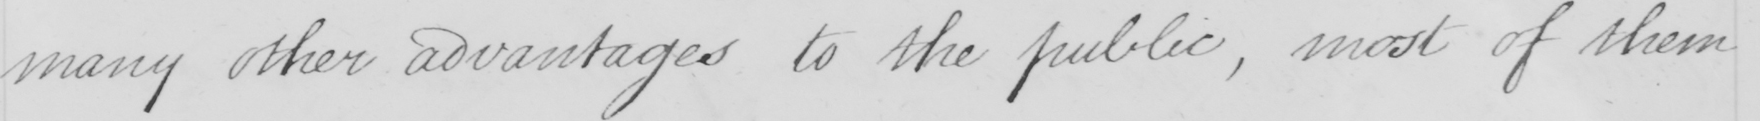Please transcribe the handwritten text in this image. many other advantages to the public , most of them 